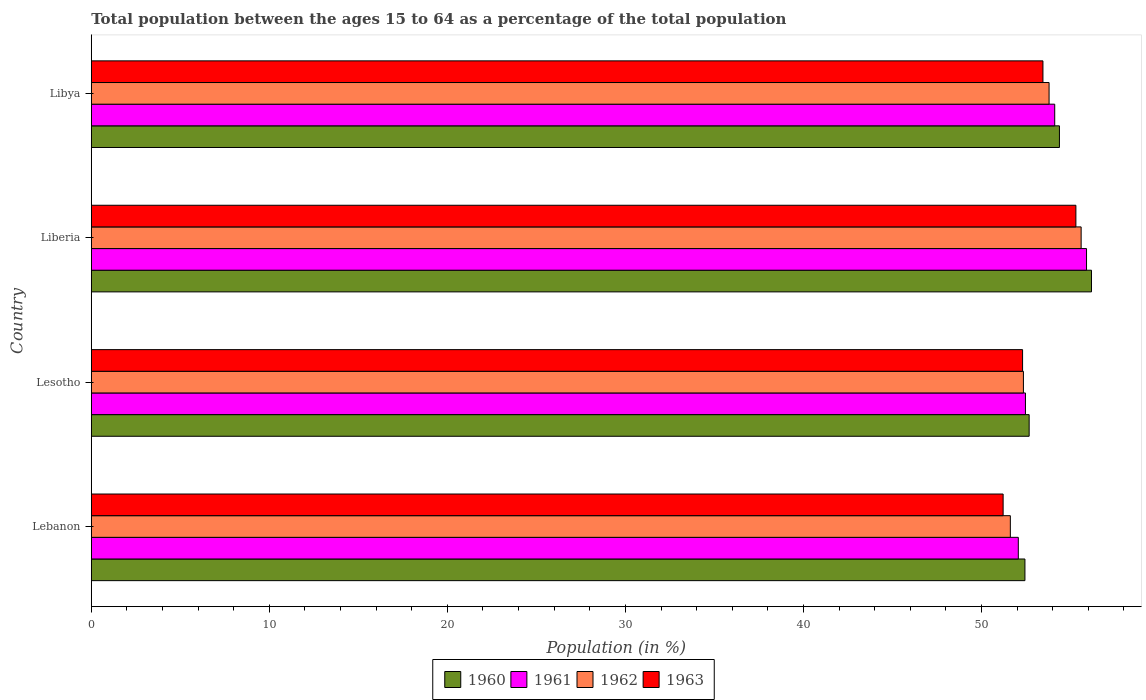How many different coloured bars are there?
Keep it short and to the point. 4. How many groups of bars are there?
Your response must be concise. 4. Are the number of bars on each tick of the Y-axis equal?
Provide a short and direct response. Yes. How many bars are there on the 2nd tick from the top?
Provide a short and direct response. 4. How many bars are there on the 4th tick from the bottom?
Your answer should be compact. 4. What is the label of the 2nd group of bars from the top?
Your answer should be compact. Liberia. What is the percentage of the population ages 15 to 64 in 1960 in Lebanon?
Provide a succinct answer. 52.44. Across all countries, what is the maximum percentage of the population ages 15 to 64 in 1962?
Provide a succinct answer. 55.6. Across all countries, what is the minimum percentage of the population ages 15 to 64 in 1963?
Provide a succinct answer. 51.21. In which country was the percentage of the population ages 15 to 64 in 1961 maximum?
Make the answer very short. Liberia. In which country was the percentage of the population ages 15 to 64 in 1962 minimum?
Provide a succinct answer. Lebanon. What is the total percentage of the population ages 15 to 64 in 1960 in the graph?
Give a very brief answer. 215.67. What is the difference between the percentage of the population ages 15 to 64 in 1961 in Lesotho and that in Libya?
Offer a very short reply. -1.64. What is the difference between the percentage of the population ages 15 to 64 in 1961 in Lebanon and the percentage of the population ages 15 to 64 in 1963 in Libya?
Your answer should be compact. -1.38. What is the average percentage of the population ages 15 to 64 in 1962 per country?
Your answer should be very brief. 53.34. What is the difference between the percentage of the population ages 15 to 64 in 1961 and percentage of the population ages 15 to 64 in 1960 in Lebanon?
Provide a short and direct response. -0.37. In how many countries, is the percentage of the population ages 15 to 64 in 1960 greater than 20 ?
Provide a short and direct response. 4. What is the ratio of the percentage of the population ages 15 to 64 in 1960 in Lebanon to that in Lesotho?
Offer a very short reply. 1. Is the percentage of the population ages 15 to 64 in 1960 in Lesotho less than that in Liberia?
Provide a short and direct response. Yes. Is the difference between the percentage of the population ages 15 to 64 in 1961 in Lesotho and Libya greater than the difference between the percentage of the population ages 15 to 64 in 1960 in Lesotho and Libya?
Provide a short and direct response. Yes. What is the difference between the highest and the second highest percentage of the population ages 15 to 64 in 1963?
Provide a succinct answer. 1.85. What is the difference between the highest and the lowest percentage of the population ages 15 to 64 in 1963?
Your answer should be very brief. 4.09. In how many countries, is the percentage of the population ages 15 to 64 in 1963 greater than the average percentage of the population ages 15 to 64 in 1963 taken over all countries?
Ensure brevity in your answer.  2. Is the sum of the percentage of the population ages 15 to 64 in 1960 in Lebanon and Liberia greater than the maximum percentage of the population ages 15 to 64 in 1963 across all countries?
Offer a very short reply. Yes. Is it the case that in every country, the sum of the percentage of the population ages 15 to 64 in 1960 and percentage of the population ages 15 to 64 in 1961 is greater than the sum of percentage of the population ages 15 to 64 in 1962 and percentage of the population ages 15 to 64 in 1963?
Your answer should be very brief. No. Is it the case that in every country, the sum of the percentage of the population ages 15 to 64 in 1960 and percentage of the population ages 15 to 64 in 1963 is greater than the percentage of the population ages 15 to 64 in 1962?
Offer a terse response. Yes. How many bars are there?
Offer a terse response. 16. How many countries are there in the graph?
Provide a short and direct response. 4. What is the difference between two consecutive major ticks on the X-axis?
Provide a short and direct response. 10. Does the graph contain any zero values?
Provide a short and direct response. No. How are the legend labels stacked?
Your answer should be compact. Horizontal. What is the title of the graph?
Give a very brief answer. Total population between the ages 15 to 64 as a percentage of the total population. Does "1986" appear as one of the legend labels in the graph?
Your answer should be very brief. No. What is the Population (in %) of 1960 in Lebanon?
Keep it short and to the point. 52.44. What is the Population (in %) of 1961 in Lebanon?
Make the answer very short. 52.07. What is the Population (in %) of 1962 in Lebanon?
Provide a short and direct response. 51.62. What is the Population (in %) of 1963 in Lebanon?
Your response must be concise. 51.21. What is the Population (in %) in 1960 in Lesotho?
Make the answer very short. 52.68. What is the Population (in %) in 1961 in Lesotho?
Your answer should be very brief. 52.47. What is the Population (in %) in 1962 in Lesotho?
Offer a terse response. 52.35. What is the Population (in %) in 1963 in Lesotho?
Provide a short and direct response. 52.31. What is the Population (in %) in 1960 in Liberia?
Make the answer very short. 56.18. What is the Population (in %) in 1961 in Liberia?
Provide a succinct answer. 55.9. What is the Population (in %) in 1962 in Liberia?
Ensure brevity in your answer.  55.6. What is the Population (in %) in 1963 in Liberia?
Make the answer very short. 55.3. What is the Population (in %) in 1960 in Libya?
Provide a succinct answer. 54.38. What is the Population (in %) of 1961 in Libya?
Your response must be concise. 54.11. What is the Population (in %) of 1962 in Libya?
Ensure brevity in your answer.  53.79. What is the Population (in %) in 1963 in Libya?
Keep it short and to the point. 53.45. Across all countries, what is the maximum Population (in %) of 1960?
Offer a very short reply. 56.18. Across all countries, what is the maximum Population (in %) in 1961?
Keep it short and to the point. 55.9. Across all countries, what is the maximum Population (in %) of 1962?
Offer a terse response. 55.6. Across all countries, what is the maximum Population (in %) in 1963?
Make the answer very short. 55.3. Across all countries, what is the minimum Population (in %) in 1960?
Your answer should be compact. 52.44. Across all countries, what is the minimum Population (in %) of 1961?
Make the answer very short. 52.07. Across all countries, what is the minimum Population (in %) in 1962?
Your answer should be very brief. 51.62. Across all countries, what is the minimum Population (in %) of 1963?
Your response must be concise. 51.21. What is the total Population (in %) in 1960 in the graph?
Keep it short and to the point. 215.67. What is the total Population (in %) of 1961 in the graph?
Provide a succinct answer. 214.55. What is the total Population (in %) in 1962 in the graph?
Provide a short and direct response. 213.36. What is the total Population (in %) of 1963 in the graph?
Provide a short and direct response. 212.27. What is the difference between the Population (in %) in 1960 in Lebanon and that in Lesotho?
Provide a succinct answer. -0.24. What is the difference between the Population (in %) in 1961 in Lebanon and that in Lesotho?
Your answer should be compact. -0.4. What is the difference between the Population (in %) in 1962 in Lebanon and that in Lesotho?
Offer a very short reply. -0.73. What is the difference between the Population (in %) in 1963 in Lebanon and that in Lesotho?
Your answer should be very brief. -1.09. What is the difference between the Population (in %) of 1960 in Lebanon and that in Liberia?
Your answer should be very brief. -3.74. What is the difference between the Population (in %) in 1961 in Lebanon and that in Liberia?
Offer a very short reply. -3.83. What is the difference between the Population (in %) in 1962 in Lebanon and that in Liberia?
Your response must be concise. -3.98. What is the difference between the Population (in %) of 1963 in Lebanon and that in Liberia?
Offer a very short reply. -4.09. What is the difference between the Population (in %) of 1960 in Lebanon and that in Libya?
Give a very brief answer. -1.94. What is the difference between the Population (in %) of 1961 in Lebanon and that in Libya?
Your answer should be compact. -2.04. What is the difference between the Population (in %) in 1962 in Lebanon and that in Libya?
Your answer should be compact. -2.18. What is the difference between the Population (in %) in 1963 in Lebanon and that in Libya?
Your answer should be very brief. -2.24. What is the difference between the Population (in %) in 1960 in Lesotho and that in Liberia?
Your response must be concise. -3.5. What is the difference between the Population (in %) of 1961 in Lesotho and that in Liberia?
Keep it short and to the point. -3.43. What is the difference between the Population (in %) of 1962 in Lesotho and that in Liberia?
Your response must be concise. -3.24. What is the difference between the Population (in %) of 1963 in Lesotho and that in Liberia?
Your response must be concise. -2.99. What is the difference between the Population (in %) of 1960 in Lesotho and that in Libya?
Your response must be concise. -1.7. What is the difference between the Population (in %) of 1961 in Lesotho and that in Libya?
Your answer should be very brief. -1.64. What is the difference between the Population (in %) in 1962 in Lesotho and that in Libya?
Offer a terse response. -1.44. What is the difference between the Population (in %) of 1963 in Lesotho and that in Libya?
Give a very brief answer. -1.14. What is the difference between the Population (in %) of 1960 in Liberia and that in Libya?
Provide a succinct answer. 1.8. What is the difference between the Population (in %) in 1961 in Liberia and that in Libya?
Make the answer very short. 1.79. What is the difference between the Population (in %) of 1962 in Liberia and that in Libya?
Provide a succinct answer. 1.8. What is the difference between the Population (in %) of 1963 in Liberia and that in Libya?
Your answer should be very brief. 1.85. What is the difference between the Population (in %) of 1960 in Lebanon and the Population (in %) of 1961 in Lesotho?
Your response must be concise. -0.03. What is the difference between the Population (in %) in 1960 in Lebanon and the Population (in %) in 1962 in Lesotho?
Keep it short and to the point. 0.08. What is the difference between the Population (in %) in 1960 in Lebanon and the Population (in %) in 1963 in Lesotho?
Your response must be concise. 0.13. What is the difference between the Population (in %) in 1961 in Lebanon and the Population (in %) in 1962 in Lesotho?
Provide a succinct answer. -0.29. What is the difference between the Population (in %) of 1961 in Lebanon and the Population (in %) of 1963 in Lesotho?
Ensure brevity in your answer.  -0.24. What is the difference between the Population (in %) of 1962 in Lebanon and the Population (in %) of 1963 in Lesotho?
Provide a succinct answer. -0.69. What is the difference between the Population (in %) of 1960 in Lebanon and the Population (in %) of 1961 in Liberia?
Your answer should be compact. -3.46. What is the difference between the Population (in %) in 1960 in Lebanon and the Population (in %) in 1962 in Liberia?
Offer a very short reply. -3.16. What is the difference between the Population (in %) in 1960 in Lebanon and the Population (in %) in 1963 in Liberia?
Offer a terse response. -2.86. What is the difference between the Population (in %) of 1961 in Lebanon and the Population (in %) of 1962 in Liberia?
Make the answer very short. -3.53. What is the difference between the Population (in %) in 1961 in Lebanon and the Population (in %) in 1963 in Liberia?
Offer a very short reply. -3.23. What is the difference between the Population (in %) of 1962 in Lebanon and the Population (in %) of 1963 in Liberia?
Ensure brevity in your answer.  -3.68. What is the difference between the Population (in %) in 1960 in Lebanon and the Population (in %) in 1961 in Libya?
Provide a short and direct response. -1.67. What is the difference between the Population (in %) in 1960 in Lebanon and the Population (in %) in 1962 in Libya?
Your answer should be very brief. -1.36. What is the difference between the Population (in %) in 1960 in Lebanon and the Population (in %) in 1963 in Libya?
Offer a terse response. -1.01. What is the difference between the Population (in %) of 1961 in Lebanon and the Population (in %) of 1962 in Libya?
Offer a terse response. -1.73. What is the difference between the Population (in %) in 1961 in Lebanon and the Population (in %) in 1963 in Libya?
Provide a succinct answer. -1.38. What is the difference between the Population (in %) of 1962 in Lebanon and the Population (in %) of 1963 in Libya?
Your response must be concise. -1.83. What is the difference between the Population (in %) of 1960 in Lesotho and the Population (in %) of 1961 in Liberia?
Offer a very short reply. -3.22. What is the difference between the Population (in %) of 1960 in Lesotho and the Population (in %) of 1962 in Liberia?
Give a very brief answer. -2.92. What is the difference between the Population (in %) of 1960 in Lesotho and the Population (in %) of 1963 in Liberia?
Provide a succinct answer. -2.63. What is the difference between the Population (in %) of 1961 in Lesotho and the Population (in %) of 1962 in Liberia?
Your answer should be very brief. -3.13. What is the difference between the Population (in %) of 1961 in Lesotho and the Population (in %) of 1963 in Liberia?
Offer a terse response. -2.83. What is the difference between the Population (in %) in 1962 in Lesotho and the Population (in %) in 1963 in Liberia?
Give a very brief answer. -2.95. What is the difference between the Population (in %) of 1960 in Lesotho and the Population (in %) of 1961 in Libya?
Your response must be concise. -1.44. What is the difference between the Population (in %) of 1960 in Lesotho and the Population (in %) of 1962 in Libya?
Your answer should be very brief. -1.12. What is the difference between the Population (in %) in 1960 in Lesotho and the Population (in %) in 1963 in Libya?
Your answer should be very brief. -0.77. What is the difference between the Population (in %) of 1961 in Lesotho and the Population (in %) of 1962 in Libya?
Ensure brevity in your answer.  -1.33. What is the difference between the Population (in %) of 1961 in Lesotho and the Population (in %) of 1963 in Libya?
Your response must be concise. -0.98. What is the difference between the Population (in %) in 1962 in Lesotho and the Population (in %) in 1963 in Libya?
Provide a short and direct response. -1.1. What is the difference between the Population (in %) in 1960 in Liberia and the Population (in %) in 1961 in Libya?
Ensure brevity in your answer.  2.06. What is the difference between the Population (in %) in 1960 in Liberia and the Population (in %) in 1962 in Libya?
Keep it short and to the point. 2.38. What is the difference between the Population (in %) of 1960 in Liberia and the Population (in %) of 1963 in Libya?
Your response must be concise. 2.73. What is the difference between the Population (in %) of 1961 in Liberia and the Population (in %) of 1962 in Libya?
Offer a very short reply. 2.1. What is the difference between the Population (in %) in 1961 in Liberia and the Population (in %) in 1963 in Libya?
Offer a very short reply. 2.45. What is the difference between the Population (in %) in 1962 in Liberia and the Population (in %) in 1963 in Libya?
Give a very brief answer. 2.15. What is the average Population (in %) of 1960 per country?
Provide a succinct answer. 53.92. What is the average Population (in %) of 1961 per country?
Provide a short and direct response. 53.64. What is the average Population (in %) of 1962 per country?
Make the answer very short. 53.34. What is the average Population (in %) of 1963 per country?
Your response must be concise. 53.07. What is the difference between the Population (in %) of 1960 and Population (in %) of 1961 in Lebanon?
Offer a very short reply. 0.37. What is the difference between the Population (in %) of 1960 and Population (in %) of 1962 in Lebanon?
Ensure brevity in your answer.  0.82. What is the difference between the Population (in %) of 1960 and Population (in %) of 1963 in Lebanon?
Keep it short and to the point. 1.22. What is the difference between the Population (in %) of 1961 and Population (in %) of 1962 in Lebanon?
Your response must be concise. 0.45. What is the difference between the Population (in %) of 1961 and Population (in %) of 1963 in Lebanon?
Your answer should be very brief. 0.85. What is the difference between the Population (in %) in 1962 and Population (in %) in 1963 in Lebanon?
Ensure brevity in your answer.  0.41. What is the difference between the Population (in %) in 1960 and Population (in %) in 1961 in Lesotho?
Offer a very short reply. 0.21. What is the difference between the Population (in %) in 1960 and Population (in %) in 1962 in Lesotho?
Your answer should be very brief. 0.32. What is the difference between the Population (in %) in 1960 and Population (in %) in 1963 in Lesotho?
Provide a short and direct response. 0.37. What is the difference between the Population (in %) in 1961 and Population (in %) in 1962 in Lesotho?
Your answer should be very brief. 0.11. What is the difference between the Population (in %) in 1961 and Population (in %) in 1963 in Lesotho?
Offer a terse response. 0.16. What is the difference between the Population (in %) in 1962 and Population (in %) in 1963 in Lesotho?
Ensure brevity in your answer.  0.05. What is the difference between the Population (in %) in 1960 and Population (in %) in 1961 in Liberia?
Give a very brief answer. 0.28. What is the difference between the Population (in %) of 1960 and Population (in %) of 1962 in Liberia?
Give a very brief answer. 0.58. What is the difference between the Population (in %) of 1960 and Population (in %) of 1963 in Liberia?
Make the answer very short. 0.88. What is the difference between the Population (in %) in 1961 and Population (in %) in 1962 in Liberia?
Offer a terse response. 0.3. What is the difference between the Population (in %) of 1961 and Population (in %) of 1963 in Liberia?
Keep it short and to the point. 0.6. What is the difference between the Population (in %) of 1962 and Population (in %) of 1963 in Liberia?
Your response must be concise. 0.3. What is the difference between the Population (in %) of 1960 and Population (in %) of 1961 in Libya?
Ensure brevity in your answer.  0.26. What is the difference between the Population (in %) in 1960 and Population (in %) in 1962 in Libya?
Your response must be concise. 0.58. What is the difference between the Population (in %) in 1960 and Population (in %) in 1963 in Libya?
Your answer should be compact. 0.93. What is the difference between the Population (in %) of 1961 and Population (in %) of 1962 in Libya?
Provide a short and direct response. 0.32. What is the difference between the Population (in %) of 1961 and Population (in %) of 1963 in Libya?
Provide a short and direct response. 0.66. What is the difference between the Population (in %) in 1962 and Population (in %) in 1963 in Libya?
Keep it short and to the point. 0.34. What is the ratio of the Population (in %) in 1963 in Lebanon to that in Lesotho?
Provide a succinct answer. 0.98. What is the ratio of the Population (in %) of 1960 in Lebanon to that in Liberia?
Make the answer very short. 0.93. What is the ratio of the Population (in %) of 1961 in Lebanon to that in Liberia?
Your answer should be very brief. 0.93. What is the ratio of the Population (in %) of 1962 in Lebanon to that in Liberia?
Offer a terse response. 0.93. What is the ratio of the Population (in %) in 1963 in Lebanon to that in Liberia?
Ensure brevity in your answer.  0.93. What is the ratio of the Population (in %) in 1960 in Lebanon to that in Libya?
Provide a succinct answer. 0.96. What is the ratio of the Population (in %) of 1961 in Lebanon to that in Libya?
Your answer should be very brief. 0.96. What is the ratio of the Population (in %) of 1962 in Lebanon to that in Libya?
Provide a short and direct response. 0.96. What is the ratio of the Population (in %) of 1963 in Lebanon to that in Libya?
Your answer should be very brief. 0.96. What is the ratio of the Population (in %) of 1960 in Lesotho to that in Liberia?
Keep it short and to the point. 0.94. What is the ratio of the Population (in %) in 1961 in Lesotho to that in Liberia?
Provide a short and direct response. 0.94. What is the ratio of the Population (in %) in 1962 in Lesotho to that in Liberia?
Make the answer very short. 0.94. What is the ratio of the Population (in %) in 1963 in Lesotho to that in Liberia?
Make the answer very short. 0.95. What is the ratio of the Population (in %) of 1960 in Lesotho to that in Libya?
Keep it short and to the point. 0.97. What is the ratio of the Population (in %) of 1961 in Lesotho to that in Libya?
Your answer should be compact. 0.97. What is the ratio of the Population (in %) in 1962 in Lesotho to that in Libya?
Ensure brevity in your answer.  0.97. What is the ratio of the Population (in %) of 1963 in Lesotho to that in Libya?
Ensure brevity in your answer.  0.98. What is the ratio of the Population (in %) of 1960 in Liberia to that in Libya?
Keep it short and to the point. 1.03. What is the ratio of the Population (in %) of 1961 in Liberia to that in Libya?
Offer a very short reply. 1.03. What is the ratio of the Population (in %) of 1962 in Liberia to that in Libya?
Your answer should be very brief. 1.03. What is the ratio of the Population (in %) of 1963 in Liberia to that in Libya?
Your answer should be compact. 1.03. What is the difference between the highest and the second highest Population (in %) of 1960?
Your response must be concise. 1.8. What is the difference between the highest and the second highest Population (in %) in 1961?
Your answer should be very brief. 1.79. What is the difference between the highest and the second highest Population (in %) of 1962?
Ensure brevity in your answer.  1.8. What is the difference between the highest and the second highest Population (in %) in 1963?
Ensure brevity in your answer.  1.85. What is the difference between the highest and the lowest Population (in %) in 1960?
Provide a succinct answer. 3.74. What is the difference between the highest and the lowest Population (in %) of 1961?
Keep it short and to the point. 3.83. What is the difference between the highest and the lowest Population (in %) of 1962?
Give a very brief answer. 3.98. What is the difference between the highest and the lowest Population (in %) in 1963?
Provide a short and direct response. 4.09. 